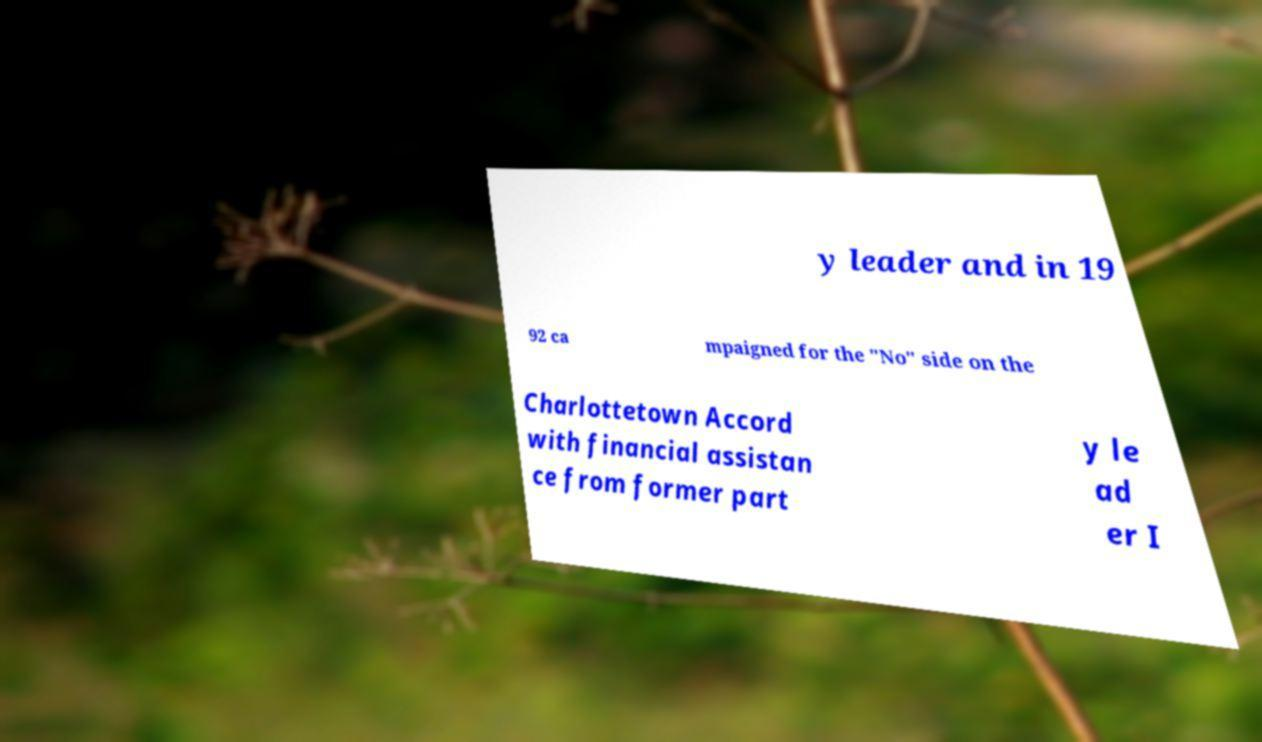There's text embedded in this image that I need extracted. Can you transcribe it verbatim? y leader and in 19 92 ca mpaigned for the "No" side on the Charlottetown Accord with financial assistan ce from former part y le ad er I 